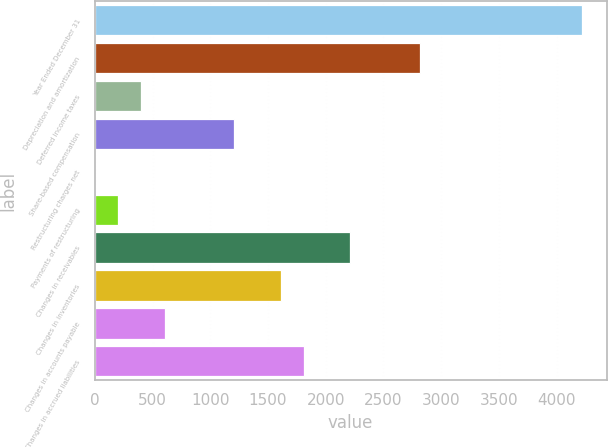Convert chart to OTSL. <chart><loc_0><loc_0><loc_500><loc_500><bar_chart><fcel>Year Ended December 31<fcel>Depreciation and amortization<fcel>Deferred income taxes<fcel>Share-based compensation<fcel>Restructuring charges net<fcel>Payments of restructuring<fcel>Changes in receivables<fcel>Changes in inventories<fcel>Changes in accounts payable<fcel>Changes in accrued liabilities<nl><fcel>4220.9<fcel>2814.6<fcel>403.8<fcel>1207.4<fcel>2<fcel>202.9<fcel>2211.9<fcel>1609.2<fcel>604.7<fcel>1810.1<nl></chart> 